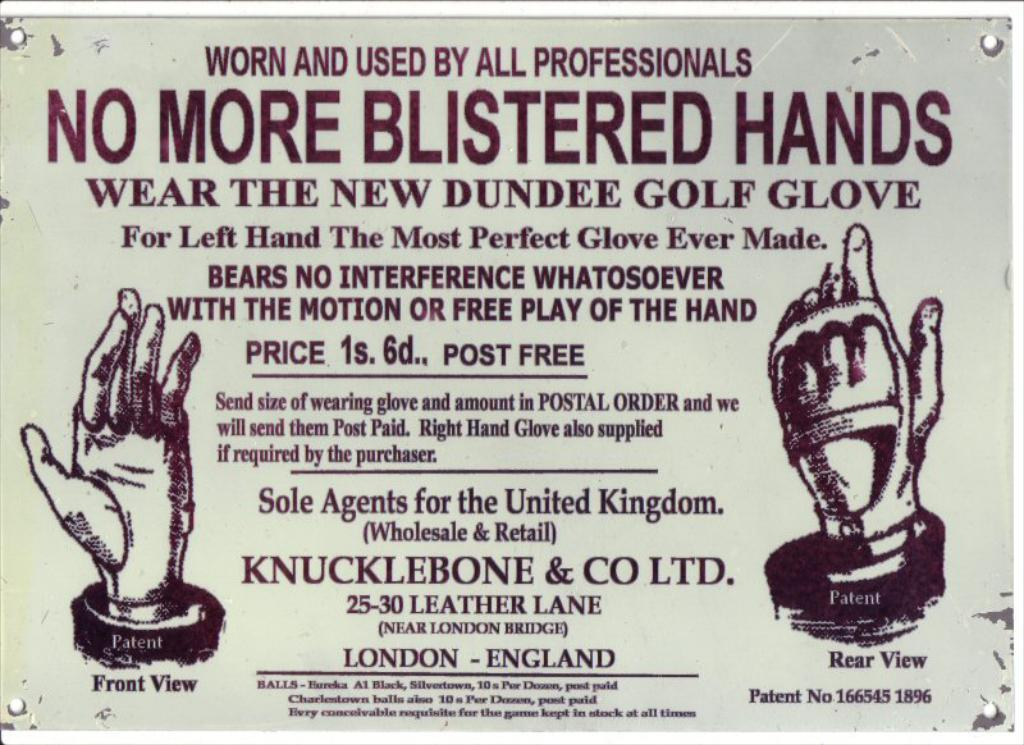Provide a one-sentence caption for the provided image. An old advertisement of gloves sold in the city of London. 